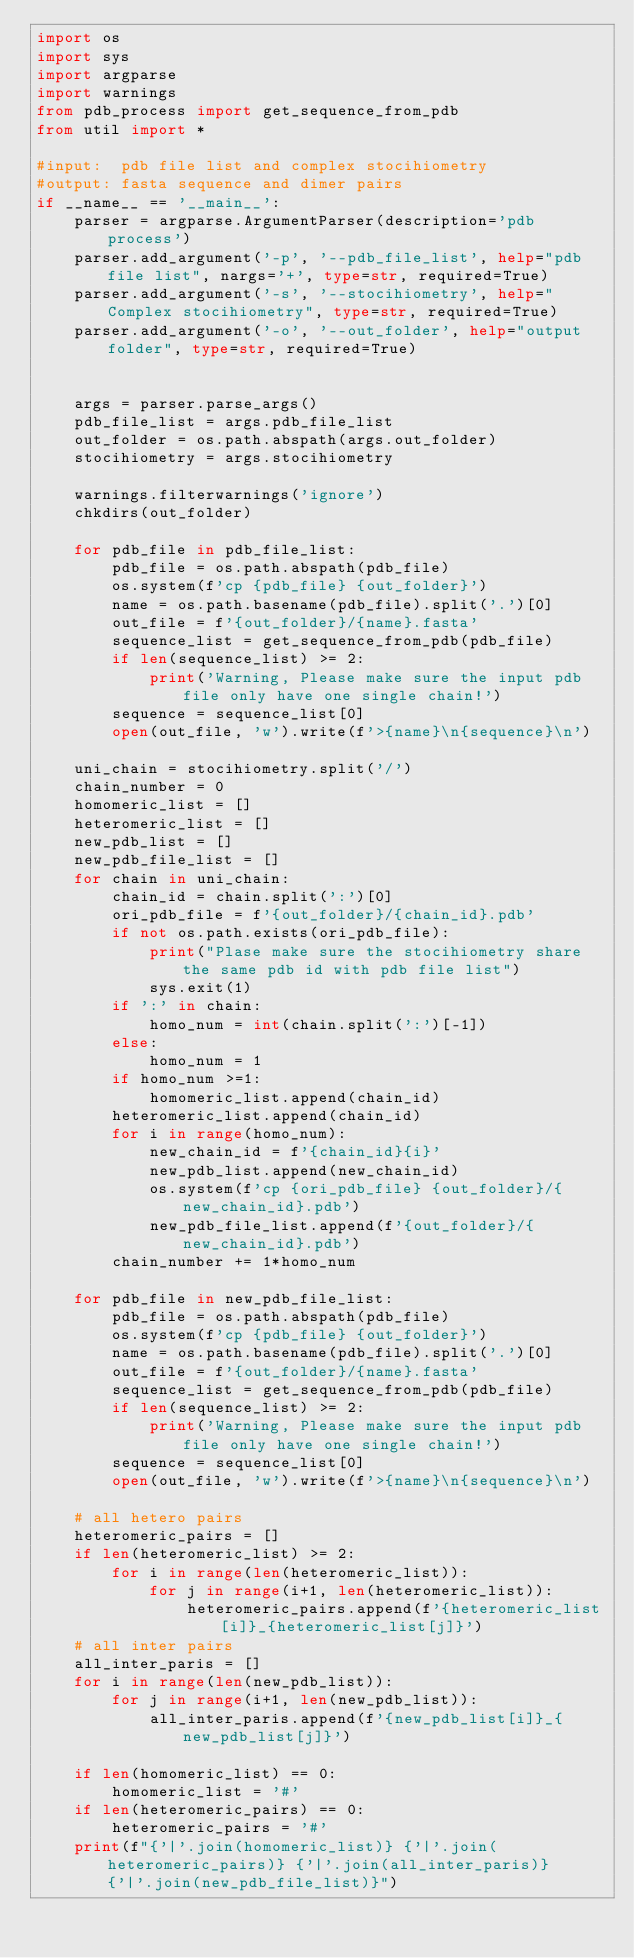Convert code to text. <code><loc_0><loc_0><loc_500><loc_500><_Python_>import os
import sys
import argparse
import warnings
from pdb_process import get_sequence_from_pdb
from util import *

#input:  pdb file list and complex stocihiometry
#output: fasta sequence and dimer pairs 
if __name__ == '__main__':
    parser = argparse.ArgumentParser(description='pdb process')
    parser.add_argument('-p', '--pdb_file_list', help="pdb file list", nargs='+', type=str, required=True)
    parser.add_argument('-s', '--stocihiometry', help="Complex stocihiometry", type=str, required=True)
    parser.add_argument('-o', '--out_folder', help="output folder", type=str, required=True)


    args = parser.parse_args()  
    pdb_file_list = args.pdb_file_list
    out_folder = os.path.abspath(args.out_folder)
    stocihiometry = args.stocihiometry

    warnings.filterwarnings('ignore')
    chkdirs(out_folder)

    for pdb_file in pdb_file_list:
        pdb_file = os.path.abspath(pdb_file)
        os.system(f'cp {pdb_file} {out_folder}')
        name = os.path.basename(pdb_file).split('.')[0]
        out_file = f'{out_folder}/{name}.fasta'
        sequence_list = get_sequence_from_pdb(pdb_file)
        if len(sequence_list) >= 2:
            print('Warning, Please make sure the input pdb file only have one single chain!')
        sequence = sequence_list[0]
        open(out_file, 'w').write(f'>{name}\n{sequence}\n')
        
    uni_chain = stocihiometry.split('/')
    chain_number = 0
    homomeric_list = []
    heteromeric_list = []
    new_pdb_list = []
    new_pdb_file_list = []
    for chain in uni_chain:
        chain_id = chain.split(':')[0]
        ori_pdb_file = f'{out_folder}/{chain_id}.pdb'
        if not os.path.exists(ori_pdb_file):
            print("Plase make sure the stocihiometry share the same pdb id with pdb file list")
            sys.exit(1)
        if ':' in chain:
            homo_num = int(chain.split(':')[-1])
        else:
            homo_num = 1
        if homo_num >=1:
            homomeric_list.append(chain_id)
        heteromeric_list.append(chain_id)
        for i in range(homo_num):
            new_chain_id = f'{chain_id}{i}'
            new_pdb_list.append(new_chain_id)
            os.system(f'cp {ori_pdb_file} {out_folder}/{new_chain_id}.pdb')
            new_pdb_file_list.append(f'{out_folder}/{new_chain_id}.pdb')
        chain_number += 1*homo_num
    
    for pdb_file in new_pdb_file_list:
        pdb_file = os.path.abspath(pdb_file)
        os.system(f'cp {pdb_file} {out_folder}')
        name = os.path.basename(pdb_file).split('.')[0]
        out_file = f'{out_folder}/{name}.fasta'
        sequence_list = get_sequence_from_pdb(pdb_file)
        if len(sequence_list) >= 2:
            print('Warning, Please make sure the input pdb file only have one single chain!')
        sequence = sequence_list[0]
        open(out_file, 'w').write(f'>{name}\n{sequence}\n')
        
    # all hetero pairs
    heteromeric_pairs = []
    if len(heteromeric_list) >= 2:
        for i in range(len(heteromeric_list)):
            for j in range(i+1, len(heteromeric_list)):
                heteromeric_pairs.append(f'{heteromeric_list[i]}_{heteromeric_list[j]}')
    # all inter pairs
    all_inter_paris = []
    for i in range(len(new_pdb_list)):
        for j in range(i+1, len(new_pdb_list)):
            all_inter_paris.append(f'{new_pdb_list[i]}_{new_pdb_list[j]}')

    if len(homomeric_list) == 0:
        homomeric_list = '#'
    if len(heteromeric_pairs) == 0:
        heteromeric_pairs = '#'
    print(f"{'|'.join(homomeric_list)} {'|'.join(heteromeric_pairs)} {'|'.join(all_inter_paris)}  {'|'.join(new_pdb_file_list)}")
</code> 